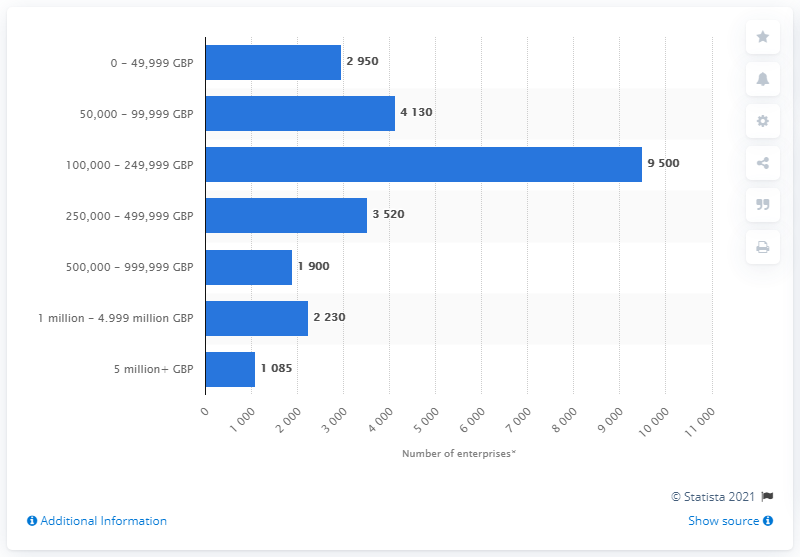Indicate a few pertinent items in this graphic. The average of all non-100,000-249,999 GBP bands is 2635.83333.. The brand with the highest number of enterprises is in the turnover size range of 100,000 to 249,999 British pounds. 